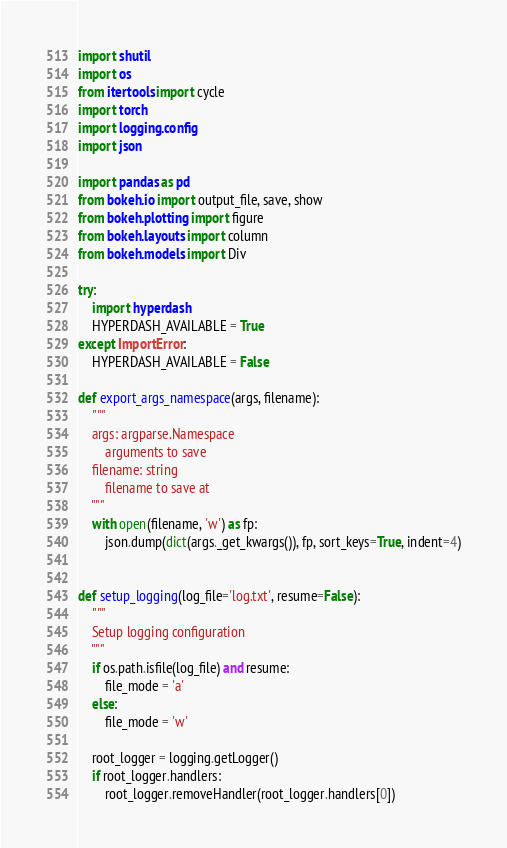<code> <loc_0><loc_0><loc_500><loc_500><_Python_>import shutil
import os
from itertools import cycle
import torch
import logging.config
import json

import pandas as pd
from bokeh.io import output_file, save, show
from bokeh.plotting import figure
from bokeh.layouts import column
from bokeh.models import Div

try:
    import hyperdash
    HYPERDASH_AVAILABLE = True
except ImportError:
    HYPERDASH_AVAILABLE = False

def export_args_namespace(args, filename):
    """
    args: argparse.Namespace
        arguments to save
    filename: string
        filename to save at
    """
    with open(filename, 'w') as fp:
        json.dump(dict(args._get_kwargs()), fp, sort_keys=True, indent=4)


def setup_logging(log_file='log.txt', resume=False):
    """
    Setup logging configuration
    """
    if os.path.isfile(log_file) and resume:
        file_mode = 'a'
    else:
        file_mode = 'w'

    root_logger = logging.getLogger()
    if root_logger.handlers:
        root_logger.removeHandler(root_logger.handlers[0])</code> 